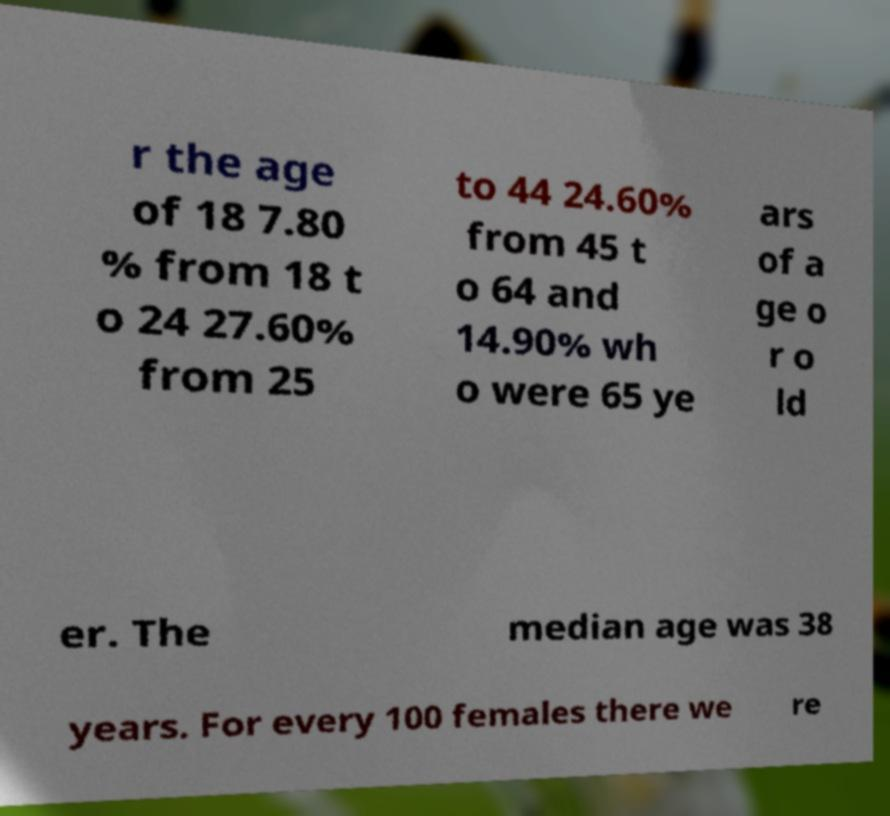For documentation purposes, I need the text within this image transcribed. Could you provide that? r the age of 18 7.80 % from 18 t o 24 27.60% from 25 to 44 24.60% from 45 t o 64 and 14.90% wh o were 65 ye ars of a ge o r o ld er. The median age was 38 years. For every 100 females there we re 